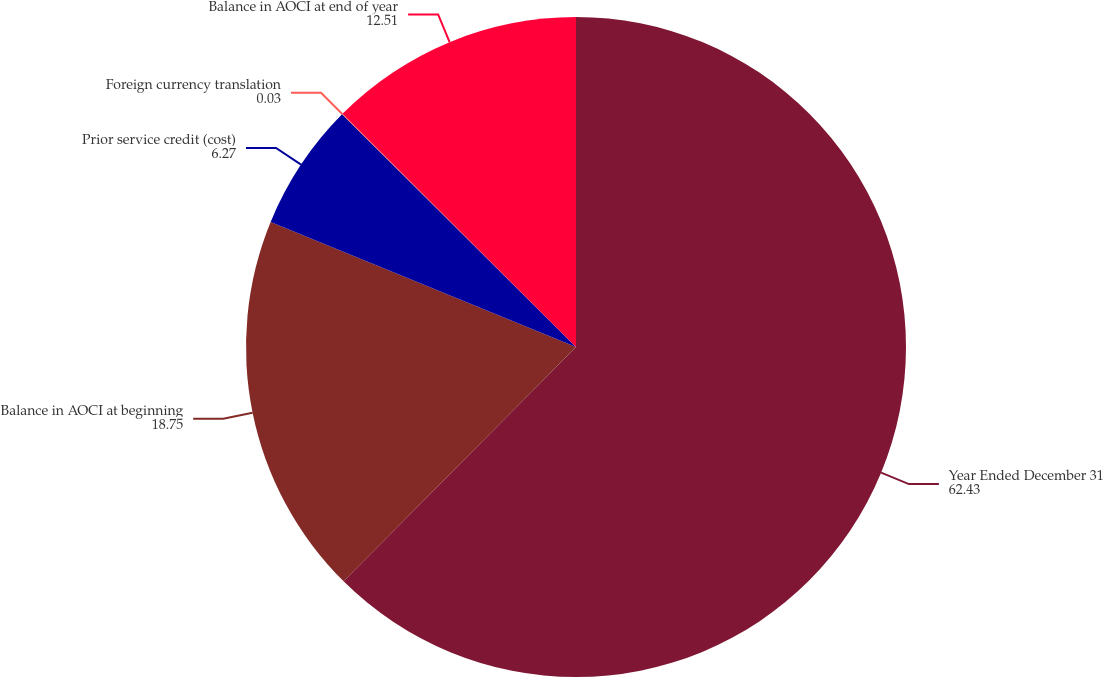Convert chart to OTSL. <chart><loc_0><loc_0><loc_500><loc_500><pie_chart><fcel>Year Ended December 31<fcel>Balance in AOCI at beginning<fcel>Prior service credit (cost)<fcel>Foreign currency translation<fcel>Balance in AOCI at end of year<nl><fcel>62.43%<fcel>18.75%<fcel>6.27%<fcel>0.03%<fcel>12.51%<nl></chart> 